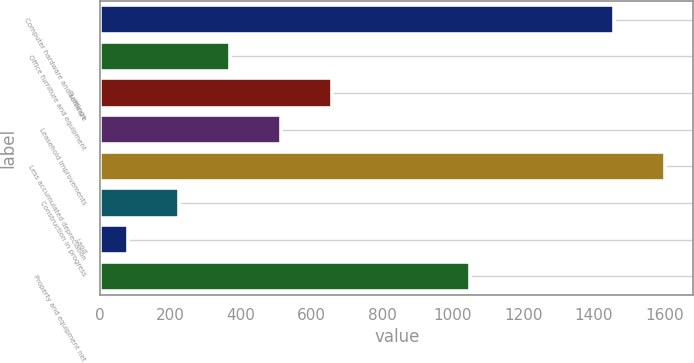Convert chart. <chart><loc_0><loc_0><loc_500><loc_500><bar_chart><fcel>Computer hardware and software<fcel>Office furniture and equipment<fcel>Buildings<fcel>Leasehold improvements<fcel>Less accumulated depreciation<fcel>Construction in progress<fcel>Land<fcel>Property and equipment net<nl><fcel>1458<fcel>369.2<fcel>659.4<fcel>514.3<fcel>1603.1<fcel>224.1<fcel>79<fcel>1050<nl></chart> 